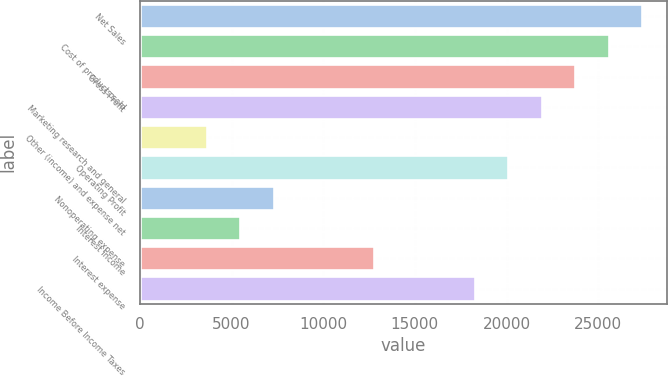<chart> <loc_0><loc_0><loc_500><loc_500><bar_chart><fcel>Net Sales<fcel>Cost of products sold<fcel>Gross Profit<fcel>Marketing research and general<fcel>Other (income) and expense net<fcel>Operating Profit<fcel>Nonoperating expense<fcel>Interest income<fcel>Interest expense<fcel>Income Before Income Taxes<nl><fcel>27397<fcel>25570.8<fcel>23744.6<fcel>21918.4<fcel>3656.51<fcel>20092.2<fcel>7308.89<fcel>5482.7<fcel>12787.5<fcel>18266<nl></chart> 